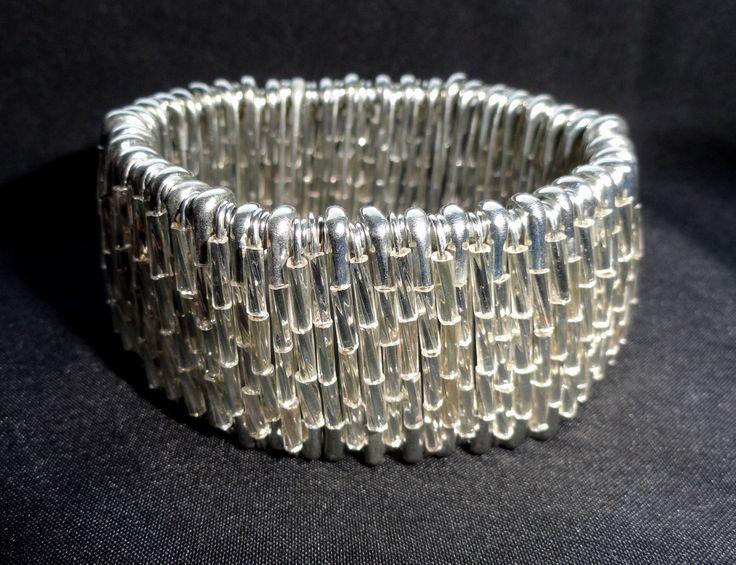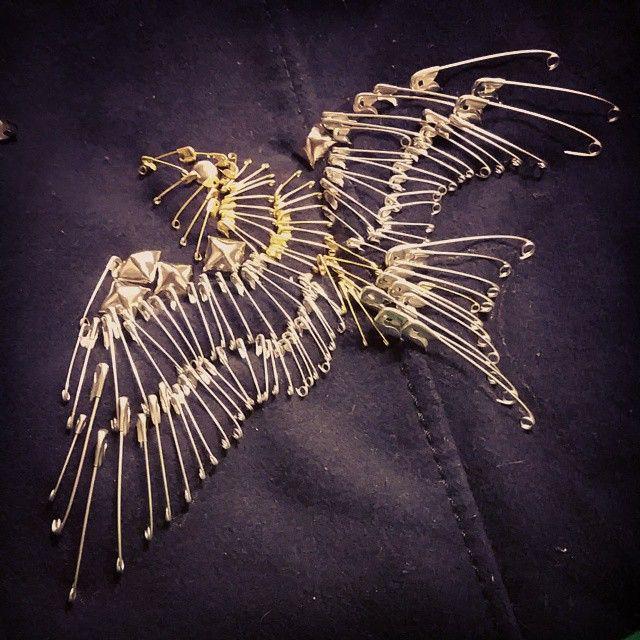The first image is the image on the left, the second image is the image on the right. For the images displayed, is the sentence "An image shows an item made of pins displayed around the neck of something." factually correct? Answer yes or no. No. 